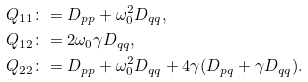Convert formula to latex. <formula><loc_0><loc_0><loc_500><loc_500>Q _ { 1 1 } & \colon = D _ { p p } + \omega _ { 0 } ^ { 2 } D _ { q q } , \\ Q _ { 1 2 } & \colon = 2 \omega _ { 0 } \gamma D _ { q q } , \\ Q _ { 2 2 } & \colon = D _ { p p } + \omega _ { 0 } ^ { 2 } D _ { q q } + 4 \gamma ( D _ { p q } + \gamma D _ { q q } ) .</formula> 